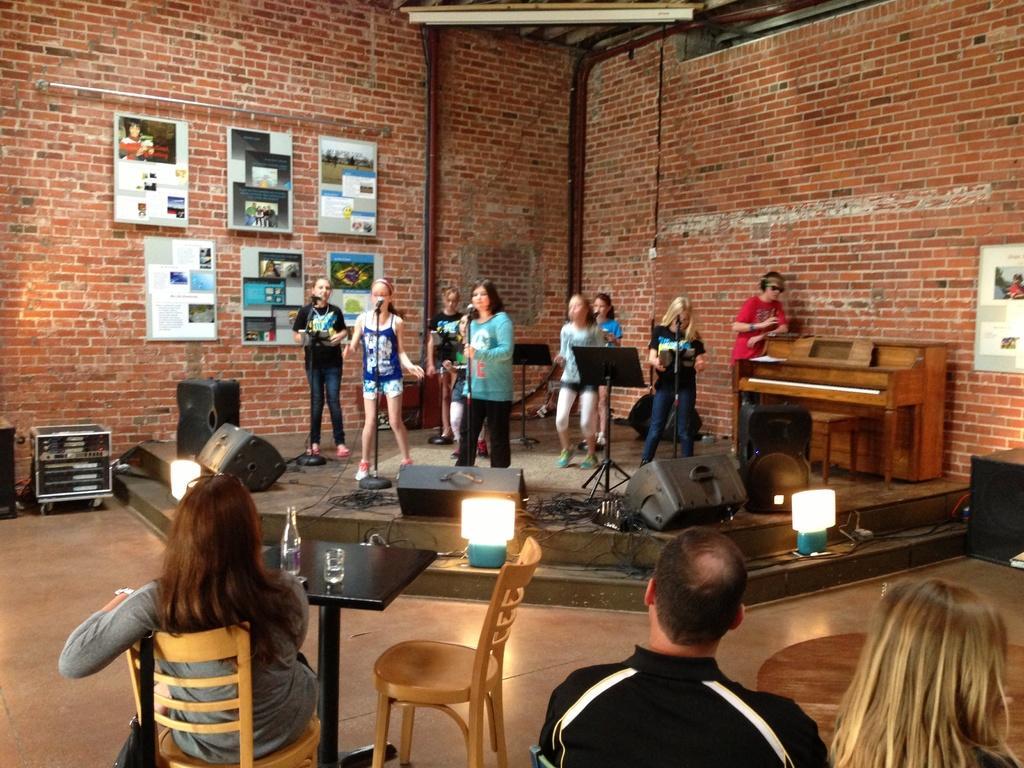How would you summarize this image in a sentence or two? As we can see in the image, there are three people sitting on chair. There is a bottle, a glass and these three people are looking at the persons who are standing and singing on mike and there is a brick wall over here. On brick wall there are some posters. 